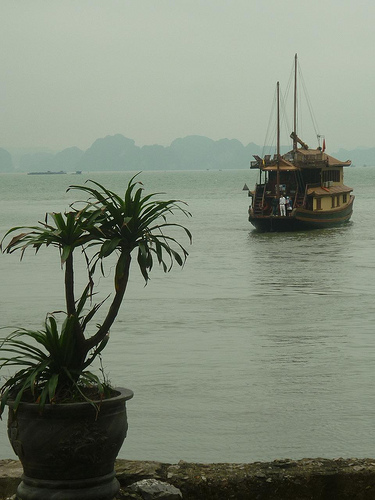<image>
Is the tree in front of the boat? Yes. The tree is positioned in front of the boat, appearing closer to the camera viewpoint. 